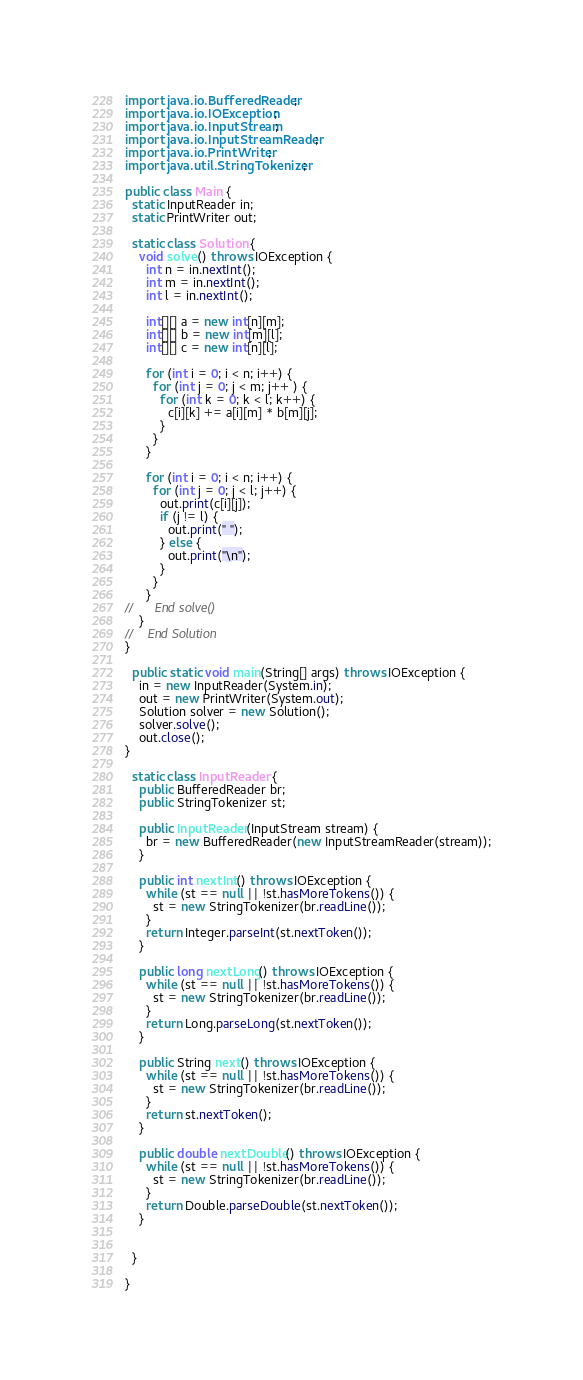Convert code to text. <code><loc_0><loc_0><loc_500><loc_500><_Java_>import java.io.BufferedReader;
import java.io.IOException;
import java.io.InputStream;
import java.io.InputStreamReader;
import java.io.PrintWriter;
import java.util.StringTokenizer;

public class Main {
  static InputReader in;
  static PrintWriter out;

  static class Solution {
    void solve() throws IOException {
      int n = in.nextInt();
      int m = in.nextInt();
      int l = in.nextInt();
      
      int[][] a = new int[n][m];
      int[][] b = new int[m][l];
      int[][] c = new int[n][l];
      
      for (int i = 0; i < n; i++) {
        for (int j = 0; j < m; j++ ) {
          for (int k = 0; k < l; k++) {
            c[i][k] += a[i][m] * b[m][j];
          }
        }
      }
      
      for (int i = 0; i < n; i++) {
        for (int j = 0; j < l; j++) {
          out.print(c[i][j]);
          if (j != l) {
            out.print(" ");
          } else {
            out.print("\n");
          }
        }
      }
//      End solve()
    }
//    End Solution
}

  public static void main(String[] args) throws IOException {
    in = new InputReader(System.in);
    out = new PrintWriter(System.out);
    Solution solver = new Solution();
    solver.solve();
    out.close();
}

  static class InputReader {
    public BufferedReader br;
    public StringTokenizer st;

    public InputReader(InputStream stream) {
      br = new BufferedReader(new InputStreamReader(stream));
    }

    public int nextInt() throws IOException {
      while (st == null || !st.hasMoreTokens()) {
        st = new StringTokenizer(br.readLine());
      }
      return Integer.parseInt(st.nextToken());
    }

    public long nextLong() throws IOException {
      while (st == null || !st.hasMoreTokens()) {
        st = new StringTokenizer(br.readLine());
      }
      return Long.parseLong(st.nextToken());
    }

    public String next() throws IOException {
      while (st == null || !st.hasMoreTokens()) {
        st = new StringTokenizer(br.readLine());
      }
      return st.nextToken();
    }

    public double nextDouble() throws IOException {
      while (st == null || !st.hasMoreTokens()) {
        st = new StringTokenizer(br.readLine());
      }
      return Double.parseDouble(st.nextToken());
    }


  }

}</code> 